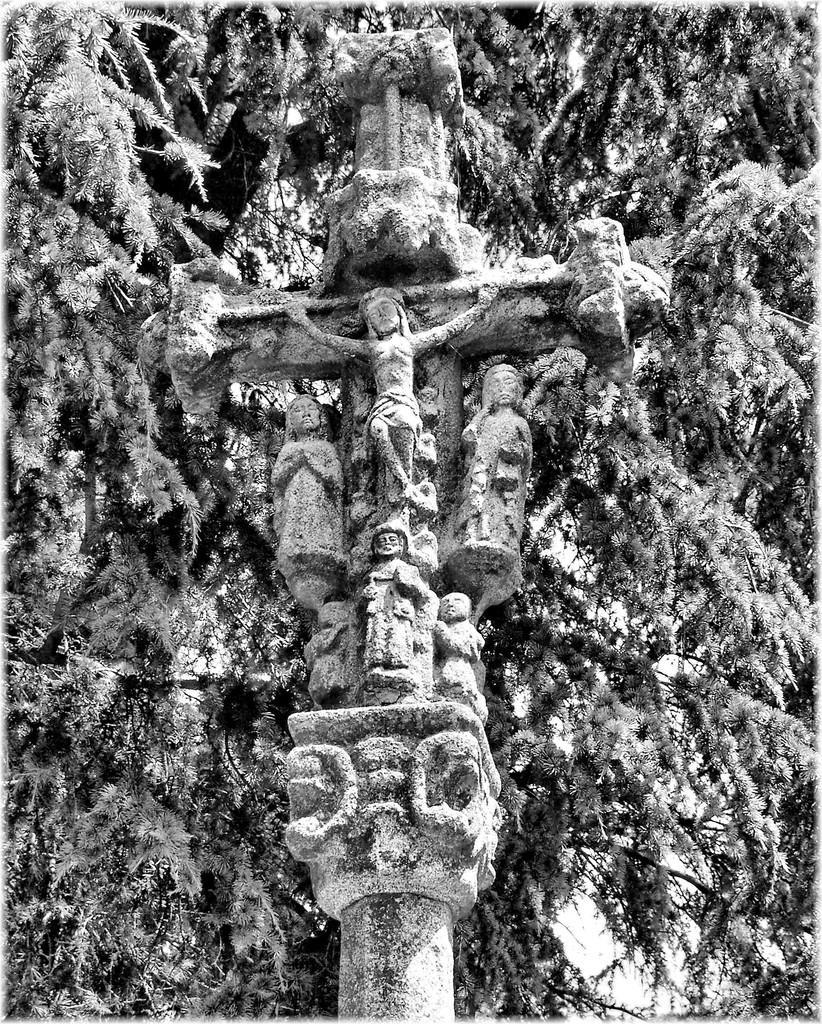In one or two sentences, can you explain what this image depicts? This is a black and white pic. We can see sculptures on a cross symbol. In the background there are trees. 